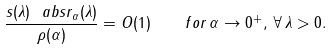Convert formula to latex. <formula><loc_0><loc_0><loc_500><loc_500>\frac { s ( \lambda ) \ a b s { r _ { \alpha } ( \lambda ) } } { \rho ( \alpha ) } = O ( 1 ) \quad f o r \, \alpha \rightarrow 0 ^ { + } , \, \forall \, \lambda > 0 .</formula> 